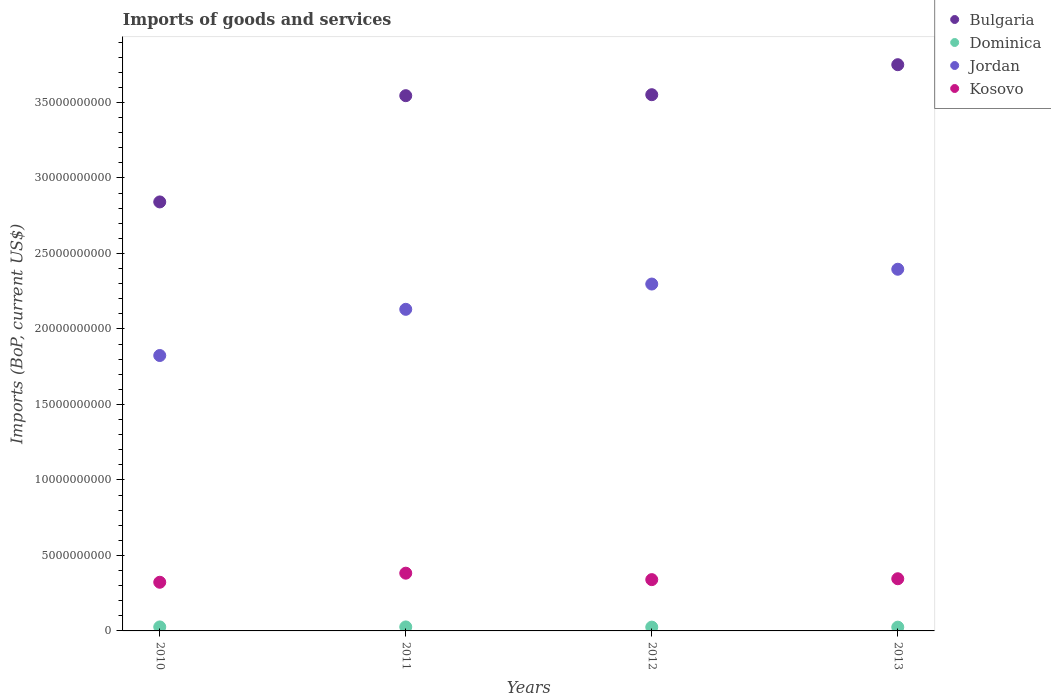What is the amount spent on imports in Jordan in 2012?
Make the answer very short. 2.30e+1. Across all years, what is the maximum amount spent on imports in Jordan?
Keep it short and to the point. 2.40e+1. Across all years, what is the minimum amount spent on imports in Jordan?
Your response must be concise. 1.82e+1. What is the total amount spent on imports in Dominica in the graph?
Keep it short and to the point. 1.03e+09. What is the difference between the amount spent on imports in Dominica in 2010 and that in 2012?
Offer a very short reply. 1.36e+07. What is the difference between the amount spent on imports in Jordan in 2012 and the amount spent on imports in Dominica in 2010?
Your answer should be compact. 2.27e+1. What is the average amount spent on imports in Kosovo per year?
Ensure brevity in your answer.  3.48e+09. In the year 2012, what is the difference between the amount spent on imports in Bulgaria and amount spent on imports in Jordan?
Keep it short and to the point. 1.25e+1. In how many years, is the amount spent on imports in Bulgaria greater than 30000000000 US$?
Provide a succinct answer. 3. What is the ratio of the amount spent on imports in Bulgaria in 2010 to that in 2013?
Ensure brevity in your answer.  0.76. Is the amount spent on imports in Kosovo in 2011 less than that in 2012?
Your response must be concise. No. Is the difference between the amount spent on imports in Bulgaria in 2012 and 2013 greater than the difference between the amount spent on imports in Jordan in 2012 and 2013?
Give a very brief answer. No. What is the difference between the highest and the second highest amount spent on imports in Jordan?
Keep it short and to the point. 9.81e+08. What is the difference between the highest and the lowest amount spent on imports in Bulgaria?
Provide a succinct answer. 9.09e+09. In how many years, is the amount spent on imports in Kosovo greater than the average amount spent on imports in Kosovo taken over all years?
Ensure brevity in your answer.  1. Is the sum of the amount spent on imports in Jordan in 2010 and 2012 greater than the maximum amount spent on imports in Bulgaria across all years?
Make the answer very short. Yes. Is it the case that in every year, the sum of the amount spent on imports in Jordan and amount spent on imports in Dominica  is greater than the sum of amount spent on imports in Bulgaria and amount spent on imports in Kosovo?
Your response must be concise. No. Is the amount spent on imports in Dominica strictly less than the amount spent on imports in Jordan over the years?
Your answer should be very brief. Yes. How many years are there in the graph?
Make the answer very short. 4. What is the difference between two consecutive major ticks on the Y-axis?
Offer a very short reply. 5.00e+09. Where does the legend appear in the graph?
Ensure brevity in your answer.  Top right. How many legend labels are there?
Give a very brief answer. 4. What is the title of the graph?
Give a very brief answer. Imports of goods and services. What is the label or title of the X-axis?
Keep it short and to the point. Years. What is the label or title of the Y-axis?
Offer a terse response. Imports (BoP, current US$). What is the Imports (BoP, current US$) of Bulgaria in 2010?
Provide a short and direct response. 2.84e+1. What is the Imports (BoP, current US$) of Dominica in 2010?
Your answer should be compact. 2.65e+08. What is the Imports (BoP, current US$) in Jordan in 2010?
Ensure brevity in your answer.  1.82e+1. What is the Imports (BoP, current US$) of Kosovo in 2010?
Keep it short and to the point. 3.22e+09. What is the Imports (BoP, current US$) in Bulgaria in 2011?
Offer a very short reply. 3.55e+1. What is the Imports (BoP, current US$) in Dominica in 2011?
Provide a succinct answer. 2.65e+08. What is the Imports (BoP, current US$) of Jordan in 2011?
Provide a succinct answer. 2.13e+1. What is the Imports (BoP, current US$) of Kosovo in 2011?
Keep it short and to the point. 3.82e+09. What is the Imports (BoP, current US$) of Bulgaria in 2012?
Your response must be concise. 3.55e+1. What is the Imports (BoP, current US$) in Dominica in 2012?
Offer a terse response. 2.51e+08. What is the Imports (BoP, current US$) in Jordan in 2012?
Give a very brief answer. 2.30e+1. What is the Imports (BoP, current US$) in Kosovo in 2012?
Give a very brief answer. 3.40e+09. What is the Imports (BoP, current US$) of Bulgaria in 2013?
Your response must be concise. 3.75e+1. What is the Imports (BoP, current US$) in Dominica in 2013?
Offer a terse response. 2.49e+08. What is the Imports (BoP, current US$) of Jordan in 2013?
Offer a very short reply. 2.40e+1. What is the Imports (BoP, current US$) of Kosovo in 2013?
Provide a short and direct response. 3.46e+09. Across all years, what is the maximum Imports (BoP, current US$) in Bulgaria?
Provide a succinct answer. 3.75e+1. Across all years, what is the maximum Imports (BoP, current US$) in Dominica?
Offer a very short reply. 2.65e+08. Across all years, what is the maximum Imports (BoP, current US$) in Jordan?
Offer a very short reply. 2.40e+1. Across all years, what is the maximum Imports (BoP, current US$) of Kosovo?
Offer a terse response. 3.82e+09. Across all years, what is the minimum Imports (BoP, current US$) in Bulgaria?
Give a very brief answer. 2.84e+1. Across all years, what is the minimum Imports (BoP, current US$) of Dominica?
Offer a terse response. 2.49e+08. Across all years, what is the minimum Imports (BoP, current US$) in Jordan?
Keep it short and to the point. 1.82e+1. Across all years, what is the minimum Imports (BoP, current US$) in Kosovo?
Provide a short and direct response. 3.22e+09. What is the total Imports (BoP, current US$) in Bulgaria in the graph?
Your response must be concise. 1.37e+11. What is the total Imports (BoP, current US$) of Dominica in the graph?
Give a very brief answer. 1.03e+09. What is the total Imports (BoP, current US$) in Jordan in the graph?
Offer a very short reply. 8.65e+1. What is the total Imports (BoP, current US$) of Kosovo in the graph?
Give a very brief answer. 1.39e+1. What is the difference between the Imports (BoP, current US$) of Bulgaria in 2010 and that in 2011?
Offer a very short reply. -7.04e+09. What is the difference between the Imports (BoP, current US$) of Dominica in 2010 and that in 2011?
Ensure brevity in your answer.  -2.88e+05. What is the difference between the Imports (BoP, current US$) in Jordan in 2010 and that in 2011?
Give a very brief answer. -3.06e+09. What is the difference between the Imports (BoP, current US$) in Kosovo in 2010 and that in 2011?
Your response must be concise. -6.01e+08. What is the difference between the Imports (BoP, current US$) in Bulgaria in 2010 and that in 2012?
Your answer should be compact. -7.10e+09. What is the difference between the Imports (BoP, current US$) in Dominica in 2010 and that in 2012?
Provide a short and direct response. 1.36e+07. What is the difference between the Imports (BoP, current US$) of Jordan in 2010 and that in 2012?
Provide a succinct answer. -4.73e+09. What is the difference between the Imports (BoP, current US$) in Kosovo in 2010 and that in 2012?
Ensure brevity in your answer.  -1.74e+08. What is the difference between the Imports (BoP, current US$) of Bulgaria in 2010 and that in 2013?
Give a very brief answer. -9.09e+09. What is the difference between the Imports (BoP, current US$) in Dominica in 2010 and that in 2013?
Keep it short and to the point. 1.54e+07. What is the difference between the Imports (BoP, current US$) of Jordan in 2010 and that in 2013?
Your answer should be compact. -5.71e+09. What is the difference between the Imports (BoP, current US$) in Kosovo in 2010 and that in 2013?
Provide a short and direct response. -2.32e+08. What is the difference between the Imports (BoP, current US$) in Bulgaria in 2011 and that in 2012?
Ensure brevity in your answer.  -6.47e+07. What is the difference between the Imports (BoP, current US$) in Dominica in 2011 and that in 2012?
Offer a terse response. 1.39e+07. What is the difference between the Imports (BoP, current US$) of Jordan in 2011 and that in 2012?
Your answer should be very brief. -1.67e+09. What is the difference between the Imports (BoP, current US$) of Kosovo in 2011 and that in 2012?
Ensure brevity in your answer.  4.27e+08. What is the difference between the Imports (BoP, current US$) of Bulgaria in 2011 and that in 2013?
Your answer should be compact. -2.05e+09. What is the difference between the Imports (BoP, current US$) in Dominica in 2011 and that in 2013?
Offer a terse response. 1.57e+07. What is the difference between the Imports (BoP, current US$) of Jordan in 2011 and that in 2013?
Give a very brief answer. -2.65e+09. What is the difference between the Imports (BoP, current US$) in Kosovo in 2011 and that in 2013?
Offer a terse response. 3.69e+08. What is the difference between the Imports (BoP, current US$) in Bulgaria in 2012 and that in 2013?
Your response must be concise. -1.99e+09. What is the difference between the Imports (BoP, current US$) of Dominica in 2012 and that in 2013?
Your answer should be very brief. 1.85e+06. What is the difference between the Imports (BoP, current US$) of Jordan in 2012 and that in 2013?
Make the answer very short. -9.81e+08. What is the difference between the Imports (BoP, current US$) in Kosovo in 2012 and that in 2013?
Your answer should be compact. -5.86e+07. What is the difference between the Imports (BoP, current US$) in Bulgaria in 2010 and the Imports (BoP, current US$) in Dominica in 2011?
Offer a terse response. 2.81e+1. What is the difference between the Imports (BoP, current US$) of Bulgaria in 2010 and the Imports (BoP, current US$) of Jordan in 2011?
Your response must be concise. 7.11e+09. What is the difference between the Imports (BoP, current US$) of Bulgaria in 2010 and the Imports (BoP, current US$) of Kosovo in 2011?
Provide a short and direct response. 2.46e+1. What is the difference between the Imports (BoP, current US$) of Dominica in 2010 and the Imports (BoP, current US$) of Jordan in 2011?
Ensure brevity in your answer.  -2.10e+1. What is the difference between the Imports (BoP, current US$) of Dominica in 2010 and the Imports (BoP, current US$) of Kosovo in 2011?
Ensure brevity in your answer.  -3.56e+09. What is the difference between the Imports (BoP, current US$) in Jordan in 2010 and the Imports (BoP, current US$) in Kosovo in 2011?
Offer a very short reply. 1.44e+1. What is the difference between the Imports (BoP, current US$) of Bulgaria in 2010 and the Imports (BoP, current US$) of Dominica in 2012?
Give a very brief answer. 2.82e+1. What is the difference between the Imports (BoP, current US$) in Bulgaria in 2010 and the Imports (BoP, current US$) in Jordan in 2012?
Ensure brevity in your answer.  5.44e+09. What is the difference between the Imports (BoP, current US$) in Bulgaria in 2010 and the Imports (BoP, current US$) in Kosovo in 2012?
Your answer should be very brief. 2.50e+1. What is the difference between the Imports (BoP, current US$) of Dominica in 2010 and the Imports (BoP, current US$) of Jordan in 2012?
Your answer should be compact. -2.27e+1. What is the difference between the Imports (BoP, current US$) in Dominica in 2010 and the Imports (BoP, current US$) in Kosovo in 2012?
Make the answer very short. -3.13e+09. What is the difference between the Imports (BoP, current US$) in Jordan in 2010 and the Imports (BoP, current US$) in Kosovo in 2012?
Your answer should be very brief. 1.48e+1. What is the difference between the Imports (BoP, current US$) of Bulgaria in 2010 and the Imports (BoP, current US$) of Dominica in 2013?
Keep it short and to the point. 2.82e+1. What is the difference between the Imports (BoP, current US$) in Bulgaria in 2010 and the Imports (BoP, current US$) in Jordan in 2013?
Provide a succinct answer. 4.46e+09. What is the difference between the Imports (BoP, current US$) in Bulgaria in 2010 and the Imports (BoP, current US$) in Kosovo in 2013?
Provide a succinct answer. 2.50e+1. What is the difference between the Imports (BoP, current US$) of Dominica in 2010 and the Imports (BoP, current US$) of Jordan in 2013?
Your response must be concise. -2.37e+1. What is the difference between the Imports (BoP, current US$) in Dominica in 2010 and the Imports (BoP, current US$) in Kosovo in 2013?
Ensure brevity in your answer.  -3.19e+09. What is the difference between the Imports (BoP, current US$) in Jordan in 2010 and the Imports (BoP, current US$) in Kosovo in 2013?
Your answer should be very brief. 1.48e+1. What is the difference between the Imports (BoP, current US$) in Bulgaria in 2011 and the Imports (BoP, current US$) in Dominica in 2012?
Your response must be concise. 3.52e+1. What is the difference between the Imports (BoP, current US$) of Bulgaria in 2011 and the Imports (BoP, current US$) of Jordan in 2012?
Your answer should be compact. 1.25e+1. What is the difference between the Imports (BoP, current US$) in Bulgaria in 2011 and the Imports (BoP, current US$) in Kosovo in 2012?
Your answer should be very brief. 3.21e+1. What is the difference between the Imports (BoP, current US$) in Dominica in 2011 and the Imports (BoP, current US$) in Jordan in 2012?
Provide a succinct answer. -2.27e+1. What is the difference between the Imports (BoP, current US$) of Dominica in 2011 and the Imports (BoP, current US$) of Kosovo in 2012?
Your answer should be very brief. -3.13e+09. What is the difference between the Imports (BoP, current US$) in Jordan in 2011 and the Imports (BoP, current US$) in Kosovo in 2012?
Your answer should be compact. 1.79e+1. What is the difference between the Imports (BoP, current US$) of Bulgaria in 2011 and the Imports (BoP, current US$) of Dominica in 2013?
Keep it short and to the point. 3.52e+1. What is the difference between the Imports (BoP, current US$) of Bulgaria in 2011 and the Imports (BoP, current US$) of Jordan in 2013?
Provide a succinct answer. 1.15e+1. What is the difference between the Imports (BoP, current US$) in Bulgaria in 2011 and the Imports (BoP, current US$) in Kosovo in 2013?
Offer a terse response. 3.20e+1. What is the difference between the Imports (BoP, current US$) in Dominica in 2011 and the Imports (BoP, current US$) in Jordan in 2013?
Make the answer very short. -2.37e+1. What is the difference between the Imports (BoP, current US$) of Dominica in 2011 and the Imports (BoP, current US$) of Kosovo in 2013?
Your answer should be very brief. -3.19e+09. What is the difference between the Imports (BoP, current US$) of Jordan in 2011 and the Imports (BoP, current US$) of Kosovo in 2013?
Provide a short and direct response. 1.78e+1. What is the difference between the Imports (BoP, current US$) of Bulgaria in 2012 and the Imports (BoP, current US$) of Dominica in 2013?
Offer a very short reply. 3.53e+1. What is the difference between the Imports (BoP, current US$) in Bulgaria in 2012 and the Imports (BoP, current US$) in Jordan in 2013?
Ensure brevity in your answer.  1.16e+1. What is the difference between the Imports (BoP, current US$) of Bulgaria in 2012 and the Imports (BoP, current US$) of Kosovo in 2013?
Offer a very short reply. 3.21e+1. What is the difference between the Imports (BoP, current US$) of Dominica in 2012 and the Imports (BoP, current US$) of Jordan in 2013?
Make the answer very short. -2.37e+1. What is the difference between the Imports (BoP, current US$) in Dominica in 2012 and the Imports (BoP, current US$) in Kosovo in 2013?
Give a very brief answer. -3.20e+09. What is the difference between the Imports (BoP, current US$) in Jordan in 2012 and the Imports (BoP, current US$) in Kosovo in 2013?
Give a very brief answer. 1.95e+1. What is the average Imports (BoP, current US$) of Bulgaria per year?
Keep it short and to the point. 3.42e+1. What is the average Imports (BoP, current US$) in Dominica per year?
Provide a short and direct response. 2.57e+08. What is the average Imports (BoP, current US$) of Jordan per year?
Keep it short and to the point. 2.16e+1. What is the average Imports (BoP, current US$) of Kosovo per year?
Give a very brief answer. 3.48e+09. In the year 2010, what is the difference between the Imports (BoP, current US$) of Bulgaria and Imports (BoP, current US$) of Dominica?
Ensure brevity in your answer.  2.81e+1. In the year 2010, what is the difference between the Imports (BoP, current US$) of Bulgaria and Imports (BoP, current US$) of Jordan?
Your answer should be compact. 1.02e+1. In the year 2010, what is the difference between the Imports (BoP, current US$) in Bulgaria and Imports (BoP, current US$) in Kosovo?
Give a very brief answer. 2.52e+1. In the year 2010, what is the difference between the Imports (BoP, current US$) in Dominica and Imports (BoP, current US$) in Jordan?
Your answer should be very brief. -1.80e+1. In the year 2010, what is the difference between the Imports (BoP, current US$) in Dominica and Imports (BoP, current US$) in Kosovo?
Keep it short and to the point. -2.96e+09. In the year 2010, what is the difference between the Imports (BoP, current US$) of Jordan and Imports (BoP, current US$) of Kosovo?
Your answer should be very brief. 1.50e+1. In the year 2011, what is the difference between the Imports (BoP, current US$) in Bulgaria and Imports (BoP, current US$) in Dominica?
Ensure brevity in your answer.  3.52e+1. In the year 2011, what is the difference between the Imports (BoP, current US$) of Bulgaria and Imports (BoP, current US$) of Jordan?
Your answer should be very brief. 1.42e+1. In the year 2011, what is the difference between the Imports (BoP, current US$) of Bulgaria and Imports (BoP, current US$) of Kosovo?
Give a very brief answer. 3.16e+1. In the year 2011, what is the difference between the Imports (BoP, current US$) in Dominica and Imports (BoP, current US$) in Jordan?
Make the answer very short. -2.10e+1. In the year 2011, what is the difference between the Imports (BoP, current US$) of Dominica and Imports (BoP, current US$) of Kosovo?
Your answer should be very brief. -3.56e+09. In the year 2011, what is the difference between the Imports (BoP, current US$) in Jordan and Imports (BoP, current US$) in Kosovo?
Provide a succinct answer. 1.75e+1. In the year 2012, what is the difference between the Imports (BoP, current US$) in Bulgaria and Imports (BoP, current US$) in Dominica?
Your response must be concise. 3.53e+1. In the year 2012, what is the difference between the Imports (BoP, current US$) of Bulgaria and Imports (BoP, current US$) of Jordan?
Make the answer very short. 1.25e+1. In the year 2012, what is the difference between the Imports (BoP, current US$) of Bulgaria and Imports (BoP, current US$) of Kosovo?
Ensure brevity in your answer.  3.21e+1. In the year 2012, what is the difference between the Imports (BoP, current US$) of Dominica and Imports (BoP, current US$) of Jordan?
Make the answer very short. -2.27e+1. In the year 2012, what is the difference between the Imports (BoP, current US$) of Dominica and Imports (BoP, current US$) of Kosovo?
Make the answer very short. -3.15e+09. In the year 2012, what is the difference between the Imports (BoP, current US$) in Jordan and Imports (BoP, current US$) in Kosovo?
Ensure brevity in your answer.  1.96e+1. In the year 2013, what is the difference between the Imports (BoP, current US$) of Bulgaria and Imports (BoP, current US$) of Dominica?
Ensure brevity in your answer.  3.73e+1. In the year 2013, what is the difference between the Imports (BoP, current US$) of Bulgaria and Imports (BoP, current US$) of Jordan?
Provide a short and direct response. 1.35e+1. In the year 2013, what is the difference between the Imports (BoP, current US$) of Bulgaria and Imports (BoP, current US$) of Kosovo?
Make the answer very short. 3.40e+1. In the year 2013, what is the difference between the Imports (BoP, current US$) of Dominica and Imports (BoP, current US$) of Jordan?
Offer a terse response. -2.37e+1. In the year 2013, what is the difference between the Imports (BoP, current US$) of Dominica and Imports (BoP, current US$) of Kosovo?
Ensure brevity in your answer.  -3.21e+09. In the year 2013, what is the difference between the Imports (BoP, current US$) in Jordan and Imports (BoP, current US$) in Kosovo?
Your answer should be compact. 2.05e+1. What is the ratio of the Imports (BoP, current US$) of Bulgaria in 2010 to that in 2011?
Ensure brevity in your answer.  0.8. What is the ratio of the Imports (BoP, current US$) in Jordan in 2010 to that in 2011?
Give a very brief answer. 0.86. What is the ratio of the Imports (BoP, current US$) in Kosovo in 2010 to that in 2011?
Your answer should be very brief. 0.84. What is the ratio of the Imports (BoP, current US$) of Dominica in 2010 to that in 2012?
Keep it short and to the point. 1.05. What is the ratio of the Imports (BoP, current US$) of Jordan in 2010 to that in 2012?
Your response must be concise. 0.79. What is the ratio of the Imports (BoP, current US$) in Kosovo in 2010 to that in 2012?
Offer a very short reply. 0.95. What is the ratio of the Imports (BoP, current US$) in Bulgaria in 2010 to that in 2013?
Give a very brief answer. 0.76. What is the ratio of the Imports (BoP, current US$) in Dominica in 2010 to that in 2013?
Offer a very short reply. 1.06. What is the ratio of the Imports (BoP, current US$) in Jordan in 2010 to that in 2013?
Keep it short and to the point. 0.76. What is the ratio of the Imports (BoP, current US$) in Kosovo in 2010 to that in 2013?
Your answer should be compact. 0.93. What is the ratio of the Imports (BoP, current US$) of Dominica in 2011 to that in 2012?
Your answer should be very brief. 1.06. What is the ratio of the Imports (BoP, current US$) of Jordan in 2011 to that in 2012?
Give a very brief answer. 0.93. What is the ratio of the Imports (BoP, current US$) in Kosovo in 2011 to that in 2012?
Provide a short and direct response. 1.13. What is the ratio of the Imports (BoP, current US$) of Bulgaria in 2011 to that in 2013?
Your response must be concise. 0.95. What is the ratio of the Imports (BoP, current US$) in Dominica in 2011 to that in 2013?
Provide a short and direct response. 1.06. What is the ratio of the Imports (BoP, current US$) in Jordan in 2011 to that in 2013?
Give a very brief answer. 0.89. What is the ratio of the Imports (BoP, current US$) of Kosovo in 2011 to that in 2013?
Provide a succinct answer. 1.11. What is the ratio of the Imports (BoP, current US$) of Bulgaria in 2012 to that in 2013?
Give a very brief answer. 0.95. What is the ratio of the Imports (BoP, current US$) in Dominica in 2012 to that in 2013?
Ensure brevity in your answer.  1.01. What is the ratio of the Imports (BoP, current US$) in Jordan in 2012 to that in 2013?
Offer a very short reply. 0.96. What is the ratio of the Imports (BoP, current US$) in Kosovo in 2012 to that in 2013?
Offer a very short reply. 0.98. What is the difference between the highest and the second highest Imports (BoP, current US$) of Bulgaria?
Ensure brevity in your answer.  1.99e+09. What is the difference between the highest and the second highest Imports (BoP, current US$) in Dominica?
Ensure brevity in your answer.  2.88e+05. What is the difference between the highest and the second highest Imports (BoP, current US$) in Jordan?
Offer a terse response. 9.81e+08. What is the difference between the highest and the second highest Imports (BoP, current US$) in Kosovo?
Give a very brief answer. 3.69e+08. What is the difference between the highest and the lowest Imports (BoP, current US$) of Bulgaria?
Keep it short and to the point. 9.09e+09. What is the difference between the highest and the lowest Imports (BoP, current US$) of Dominica?
Offer a terse response. 1.57e+07. What is the difference between the highest and the lowest Imports (BoP, current US$) in Jordan?
Your answer should be compact. 5.71e+09. What is the difference between the highest and the lowest Imports (BoP, current US$) in Kosovo?
Provide a succinct answer. 6.01e+08. 